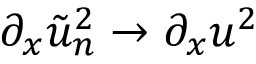Convert formula to latex. <formula><loc_0><loc_0><loc_500><loc_500>\partial _ { x } \tilde { u } _ { n } ^ { 2 } \rightarrow \partial _ { x } u ^ { 2 }</formula> 